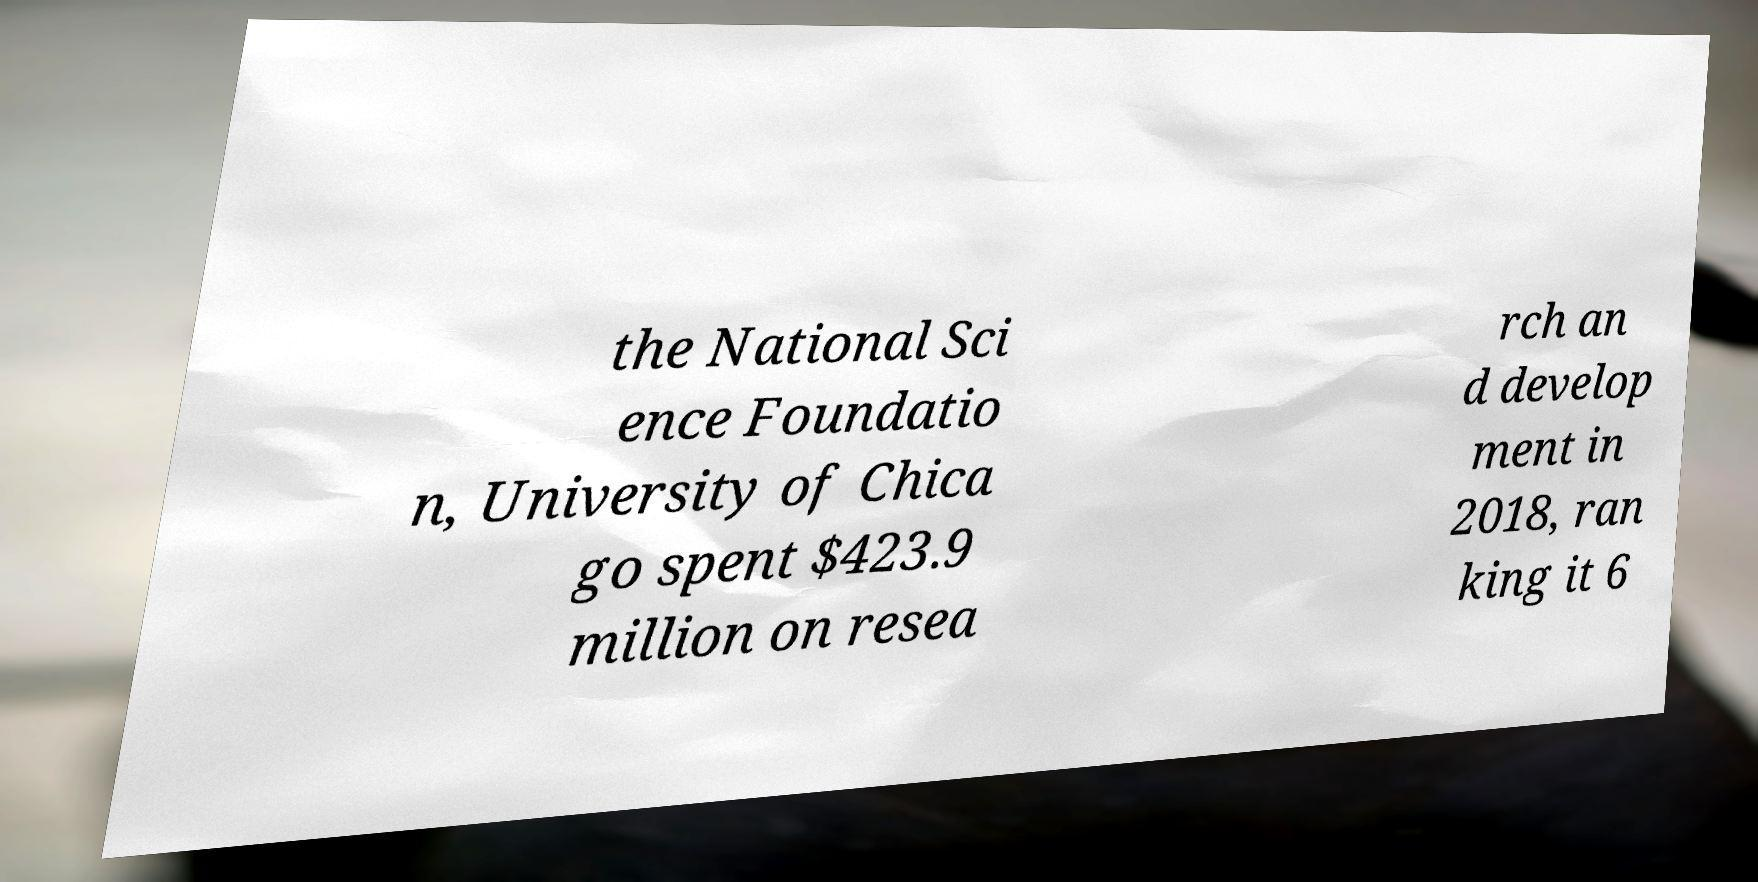Please read and relay the text visible in this image. What does it say? the National Sci ence Foundatio n, University of Chica go spent $423.9 million on resea rch an d develop ment in 2018, ran king it 6 